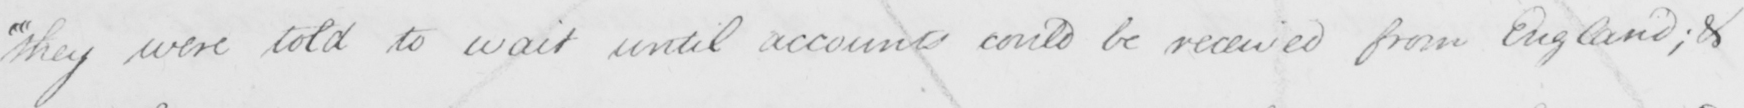Transcribe the text shown in this historical manuscript line. " they were told to wait until account could be received from England ; & 